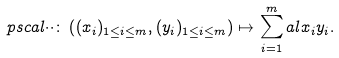Convert formula to latex. <formula><loc_0><loc_0><loc_500><loc_500>\ p s c a l { \cdot } { \cdot } \colon \left ( ( x _ { i } ) _ { 1 \leq i \leq m } , ( y _ { i } ) _ { 1 \leq i \leq m } \right ) \mapsto \sum _ { i = 1 } ^ { m } a l { x _ { i } } { y _ { i } } .</formula> 